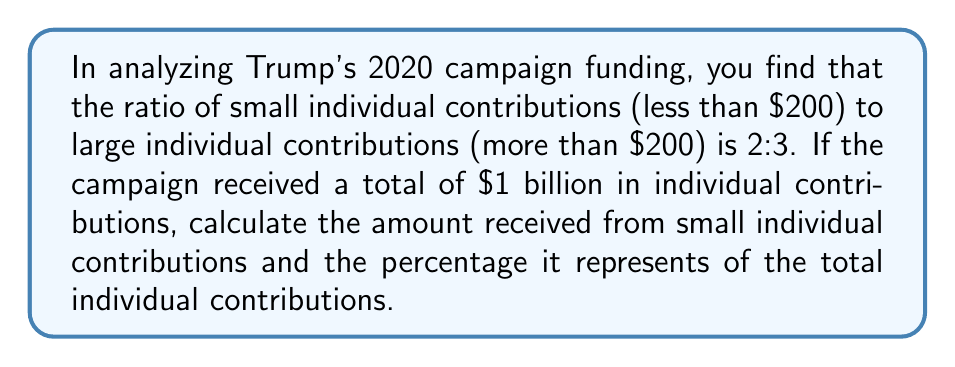Give your solution to this math problem. Let's approach this step-by-step:

1) First, we need to understand what the ratio 2:3 means in this context:
   - For every 2 parts of small contributions, there are 3 parts of large contributions
   - The total parts are 2 + 3 = 5

2) Let's define a variable for one part:
   Let $x$ represent one part of the ratio

3) Now we can set up an equation:
   $2x + 3x = 1,000,000,000$ (total contributions in dollars)
   $5x = 1,000,000,000$

4) Solve for $x$:
   $x = 1,000,000,000 \div 5 = 200,000,000$

5) Calculate small individual contributions:
   Small contributions = $2x = 2 \times 200,000,000 = 400,000,000$

6) Calculate the percentage of small contributions:
   Percentage = $\frac{\text{Small contributions}}{\text{Total contributions}} \times 100\%$
   $= \frac{400,000,000}{1,000,000,000} \times 100\% = 40\%$

Therefore, the amount received from small individual contributions is $400 million, which represents 40% of the total individual contributions.
Answer: $400 million; 40% 